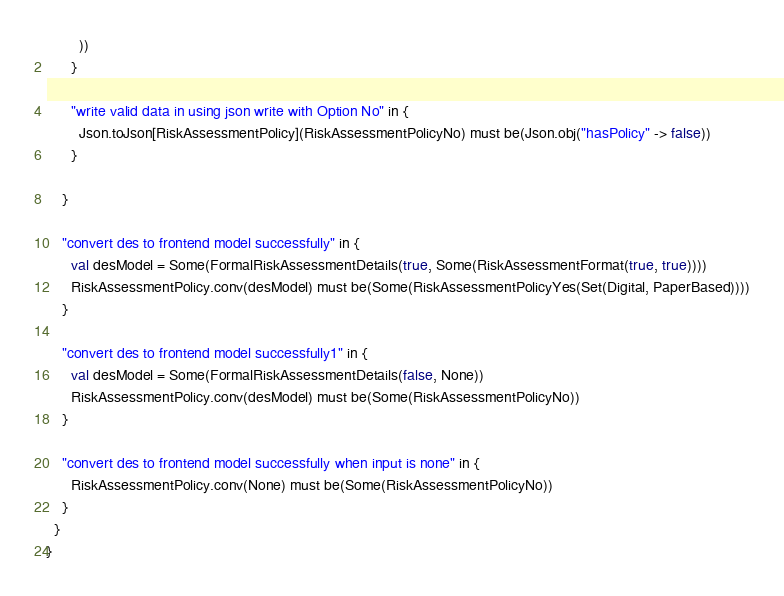Convert code to text. <code><loc_0><loc_0><loc_500><loc_500><_Scala_>        ))
      }

      "write valid data in using json write with Option No" in {
        Json.toJson[RiskAssessmentPolicy](RiskAssessmentPolicyNo) must be(Json.obj("hasPolicy" -> false))
      }

    }

    "convert des to frontend model successfully" in {
      val desModel = Some(FormalRiskAssessmentDetails(true, Some(RiskAssessmentFormat(true, true))))
      RiskAssessmentPolicy.conv(desModel) must be(Some(RiskAssessmentPolicyYes(Set(Digital, PaperBased))))
    }

    "convert des to frontend model successfully1" in {
      val desModel = Some(FormalRiskAssessmentDetails(false, None))
      RiskAssessmentPolicy.conv(desModel) must be(Some(RiskAssessmentPolicyNo))
    }

    "convert des to frontend model successfully when input is none" in {
      RiskAssessmentPolicy.conv(None) must be(Some(RiskAssessmentPolicyNo))
    }
  }
}
</code> 